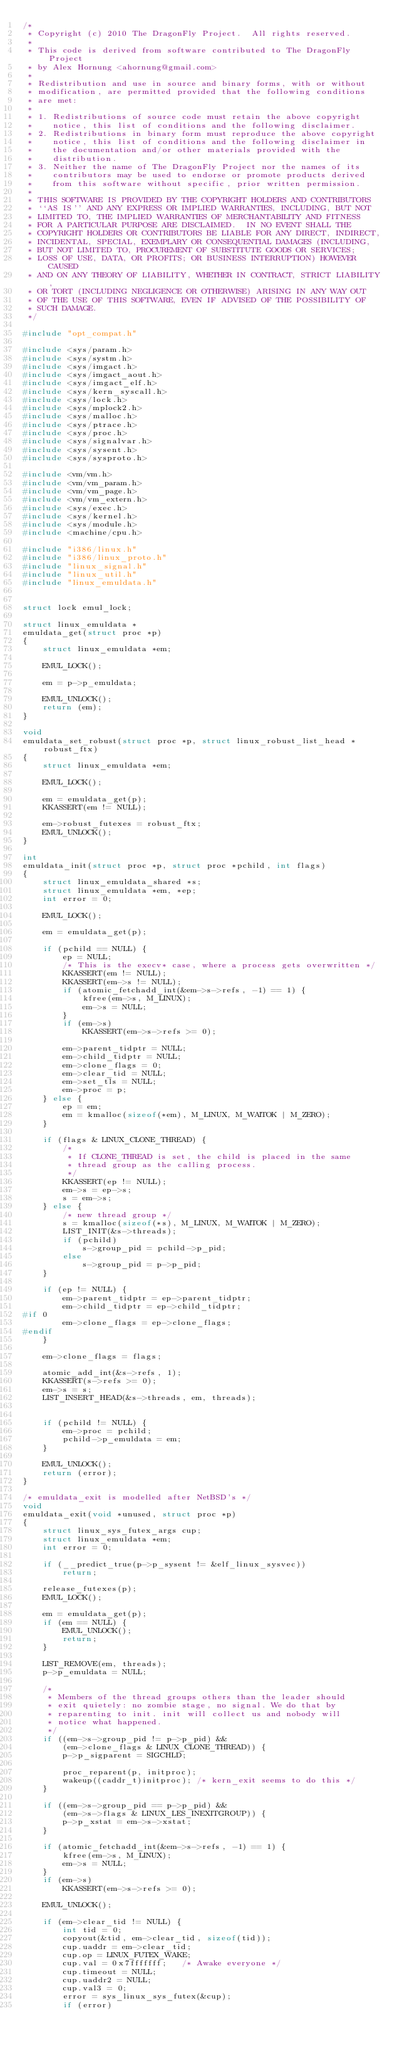<code> <loc_0><loc_0><loc_500><loc_500><_C_>/*
 * Copyright (c) 2010 The DragonFly Project.  All rights reserved.
 *
 * This code is derived from software contributed to The DragonFly Project
 * by Alex Hornung <ahornung@gmail.com>
 *
 * Redistribution and use in source and binary forms, with or without
 * modification, are permitted provided that the following conditions
 * are met:
 *
 * 1. Redistributions of source code must retain the above copyright
 *    notice, this list of conditions and the following disclaimer.
 * 2. Redistributions in binary form must reproduce the above copyright
 *    notice, this list of conditions and the following disclaimer in
 *    the documentation and/or other materials provided with the
 *    distribution.
 * 3. Neither the name of The DragonFly Project nor the names of its
 *    contributors may be used to endorse or promote products derived
 *    from this software without specific, prior written permission.
 *
 * THIS SOFTWARE IS PROVIDED BY THE COPYRIGHT HOLDERS AND CONTRIBUTORS
 * ``AS IS'' AND ANY EXPRESS OR IMPLIED WARRANTIES, INCLUDING, BUT NOT
 * LIMITED TO, THE IMPLIED WARRANTIES OF MERCHANTABILITY AND FITNESS
 * FOR A PARTICULAR PURPOSE ARE DISCLAIMED.  IN NO EVENT SHALL THE
 * COPYRIGHT HOLDERS OR CONTRIBUTORS BE LIABLE FOR ANY DIRECT, INDIRECT,
 * INCIDENTAL, SPECIAL, EXEMPLARY OR CONSEQUENTIAL DAMAGES (INCLUDING,
 * BUT NOT LIMITED TO, PROCUREMENT OF SUBSTITUTE GOODS OR SERVICES;
 * LOSS OF USE, DATA, OR PROFITS; OR BUSINESS INTERRUPTION) HOWEVER CAUSED
 * AND ON ANY THEORY OF LIABILITY, WHETHER IN CONTRACT, STRICT LIABILITY,
 * OR TORT (INCLUDING NEGLIGENCE OR OTHERWISE) ARISING IN ANY WAY OUT
 * OF THE USE OF THIS SOFTWARE, EVEN IF ADVISED OF THE POSSIBILITY OF
 * SUCH DAMAGE.
 */

#include "opt_compat.h"

#include <sys/param.h>
#include <sys/systm.h>
#include <sys/imgact.h>
#include <sys/imgact_aout.h>
#include <sys/imgact_elf.h>
#include <sys/kern_syscall.h>
#include <sys/lock.h>
#include <sys/mplock2.h>
#include <sys/malloc.h>
#include <sys/ptrace.h>
#include <sys/proc.h>
#include <sys/signalvar.h>
#include <sys/sysent.h>
#include <sys/sysproto.h>

#include <vm/vm.h>
#include <vm/vm_param.h>
#include <vm/vm_page.h>
#include <vm/vm_extern.h>
#include <sys/exec.h>
#include <sys/kernel.h>
#include <sys/module.h>
#include <machine/cpu.h>

#include "i386/linux.h"
#include "i386/linux_proto.h"
#include "linux_signal.h"
#include "linux_util.h"
#include "linux_emuldata.h"


struct lock emul_lock;

struct linux_emuldata *
emuldata_get(struct proc *p)
{
	struct linux_emuldata *em;

	EMUL_LOCK();

	em = p->p_emuldata;

	EMUL_UNLOCK();
	return (em);
}

void
emuldata_set_robust(struct proc *p, struct linux_robust_list_head *robust_ftx)
{
	struct linux_emuldata *em;

	EMUL_LOCK();

	em = emuldata_get(p);
	KKASSERT(em != NULL);

	em->robust_futexes = robust_ftx;
	EMUL_UNLOCK();
}

int
emuldata_init(struct proc *p, struct proc *pchild, int flags)
{
	struct linux_emuldata_shared *s;
	struct linux_emuldata *em, *ep;
	int error = 0;

	EMUL_LOCK();

	em = emuldata_get(p);

	if (pchild == NULL) {
		ep = NULL;
		/* This is the execv* case, where a process gets overwritten */
		KKASSERT(em != NULL);
		KKASSERT(em->s != NULL);
		if (atomic_fetchadd_int(&em->s->refs, -1) == 1) {
			kfree(em->s, M_LINUX); 
			em->s = NULL;
		}
		if (em->s)
			KKASSERT(em->s->refs >= 0);
		
		em->parent_tidptr = NULL;
		em->child_tidptr = NULL;
		em->clone_flags = 0;
		em->clear_tid = NULL;
		em->set_tls = NULL;
		em->proc = p;
	} else {
		ep = em;
		em = kmalloc(sizeof(*em), M_LINUX, M_WAITOK | M_ZERO);
	}

	if (flags & LINUX_CLONE_THREAD) {
		/*
		 * If CLONE_THREAD is set, the child is placed in the same
		 * thread group as the calling process.
		 */
		KKASSERT(ep != NULL);
		em->s = ep->s;
		s = em->s;
	} else {
		/* new thread group */
		s = kmalloc(sizeof(*s), M_LINUX, M_WAITOK | M_ZERO);
		LIST_INIT(&s->threads);
		if (pchild)
			s->group_pid = pchild->p_pid;
		else
			s->group_pid = p->p_pid;
	}

	if (ep != NULL) {
		em->parent_tidptr = ep->parent_tidptr;
		em->child_tidptr = ep->child_tidptr;
#if 0
		em->clone_flags = ep->clone_flags;
#endif
	}

	em->clone_flags = flags;

	atomic_add_int(&s->refs, 1);
	KKASSERT(s->refs >= 0);
	em->s = s;
	LIST_INSERT_HEAD(&s->threads, em, threads);

	
	if (pchild != NULL) {
		em->proc = pchild;
		pchild->p_emuldata = em;
	}

	EMUL_UNLOCK();
	return (error);
}

/* emuldata_exit is modelled after NetBSD's */
void
emuldata_exit(void *unused, struct proc *p)
{
	struct linux_sys_futex_args cup;
	struct linux_emuldata *em;
	int error = 0;

	if (__predict_true(p->p_sysent != &elf_linux_sysvec))
		return;

	release_futexes(p);
	EMUL_LOCK();

	em = emuldata_get(p);
	if (em == NULL) {
		EMUL_UNLOCK();
		return;
	}

	LIST_REMOVE(em, threads);
	p->p_emuldata = NULL;

	/*
	 * Members of the thread groups others than the leader should
	 * exit quietely: no zombie stage, no signal. We do that by
	 * reparenting to init. init will collect us and nobody will
	 * notice what happened.
	 */
	if ((em->s->group_pid != p->p_pid) &&
	    (em->clone_flags & LINUX_CLONE_THREAD)) {
		p->p_sigparent = SIGCHLD;

		proc_reparent(p, initproc);
		wakeup((caddr_t)initproc); /* kern_exit seems to do this */
	}

	if ((em->s->group_pid == p->p_pid) &&
	    (em->s->flags & LINUX_LES_INEXITGROUP)) {
		p->p_xstat = em->s->xstat;
	}

	if (atomic_fetchadd_int(&em->s->refs, -1) == 1) {
		kfree(em->s, M_LINUX);
		em->s = NULL;
	}
	if (em->s)
		KKASSERT(em->s->refs >= 0);

	EMUL_UNLOCK();

	if (em->clear_tid != NULL) {
		int tid = 0;
		copyout(&tid, em->clear_tid, sizeof(tid));
		cup.uaddr = em->clear_tid;
		cup.op = LINUX_FUTEX_WAKE;
		cup.val = 0x7fffffff;	/* Awake everyone */
		cup.timeout = NULL;
		cup.uaddr2 = NULL;
		cup.val3 = 0;
		error = sys_linux_sys_futex(&cup);
		if (error)</code> 